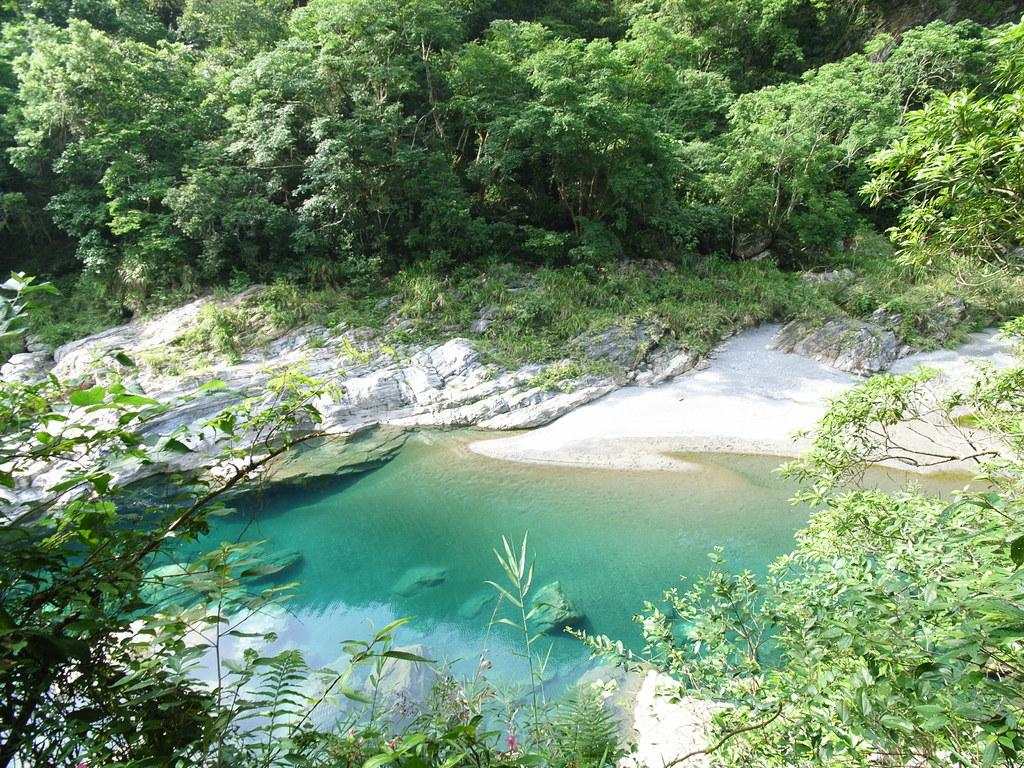What is the main feature in the center of the image? There is a lake in the center of the image. What type of vegetation can be seen in the image? There are trees visible in the image. What other objects or features can be seen in the image? There are rocks in the image. How does the lake get twisted during the earthquake in the image? There is no earthquake present in the image, and therefore no such twisting can be observed. 